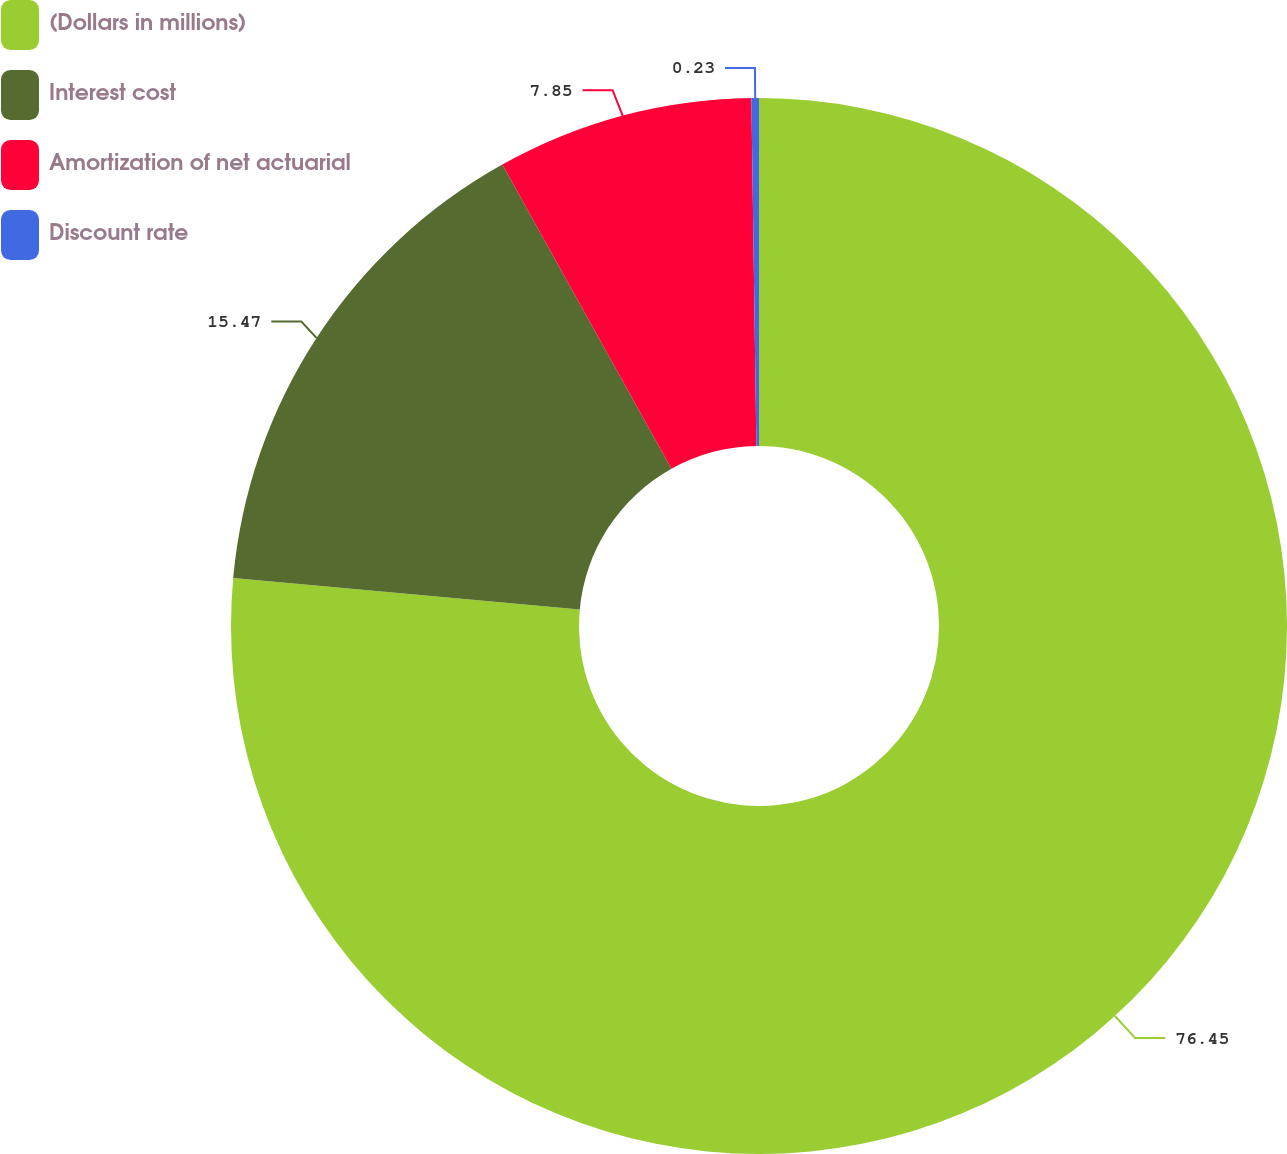Convert chart to OTSL. <chart><loc_0><loc_0><loc_500><loc_500><pie_chart><fcel>(Dollars in millions)<fcel>Interest cost<fcel>Amortization of net actuarial<fcel>Discount rate<nl><fcel>76.45%<fcel>15.47%<fcel>7.85%<fcel>0.23%<nl></chart> 